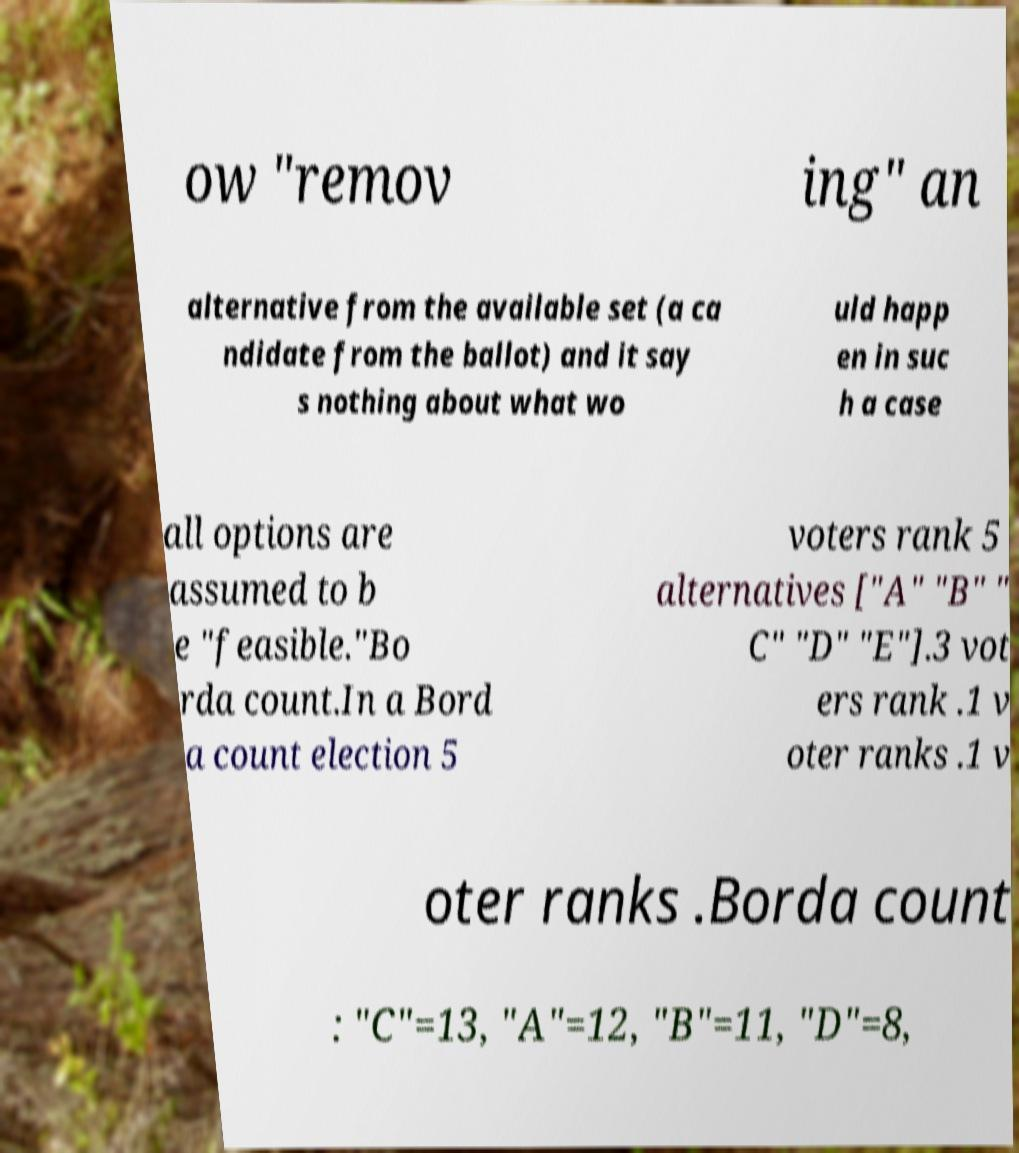What messages or text are displayed in this image? I need them in a readable, typed format. ow "remov ing" an alternative from the available set (a ca ndidate from the ballot) and it say s nothing about what wo uld happ en in suc h a case all options are assumed to b e "feasible."Bo rda count.In a Bord a count election 5 voters rank 5 alternatives ["A" "B" " C" "D" "E"].3 vot ers rank .1 v oter ranks .1 v oter ranks .Borda count : "C"=13, "A"=12, "B"=11, "D"=8, 